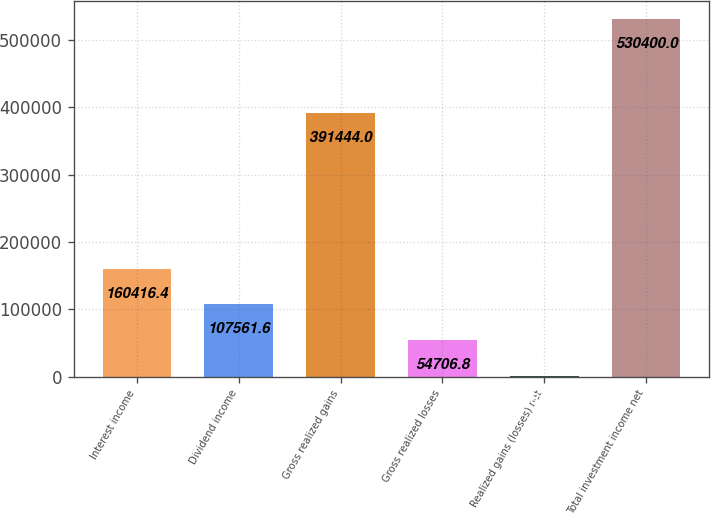Convert chart to OTSL. <chart><loc_0><loc_0><loc_500><loc_500><bar_chart><fcel>Interest income<fcel>Dividend income<fcel>Gross realized gains<fcel>Gross realized losses<fcel>Realized gains (losses) net<fcel>Total investment income net<nl><fcel>160416<fcel>107562<fcel>391444<fcel>54706.8<fcel>1852<fcel>530400<nl></chart> 